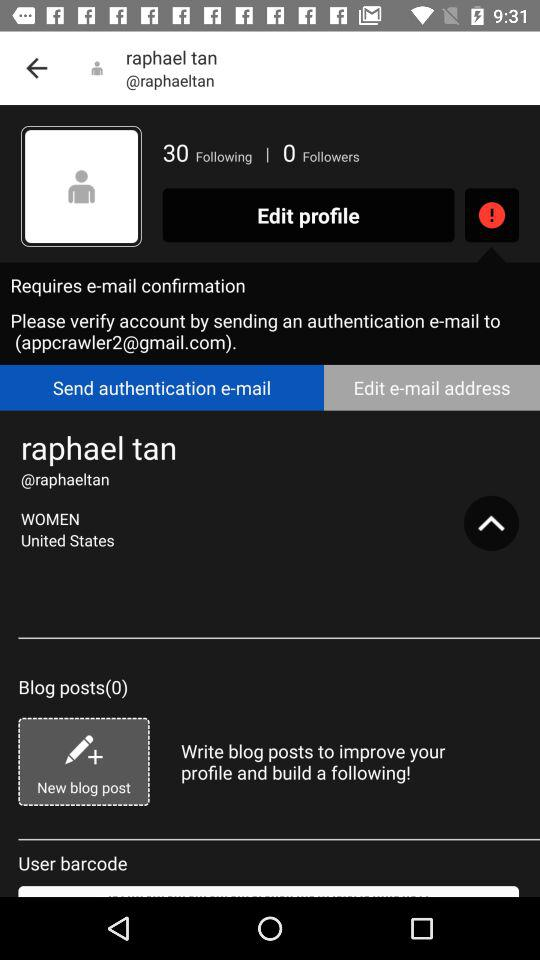Which tab is selected?
When the provided information is insufficient, respond with <no answer>. <no answer> 